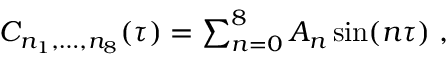<formula> <loc_0><loc_0><loc_500><loc_500>\begin{array} { r } { C _ { n _ { 1 } , \dots , n _ { 8 } } ( \tau ) = \sum _ { n = 0 } ^ { 8 } A _ { n } \sin ( n \tau ) \, , } \end{array}</formula> 